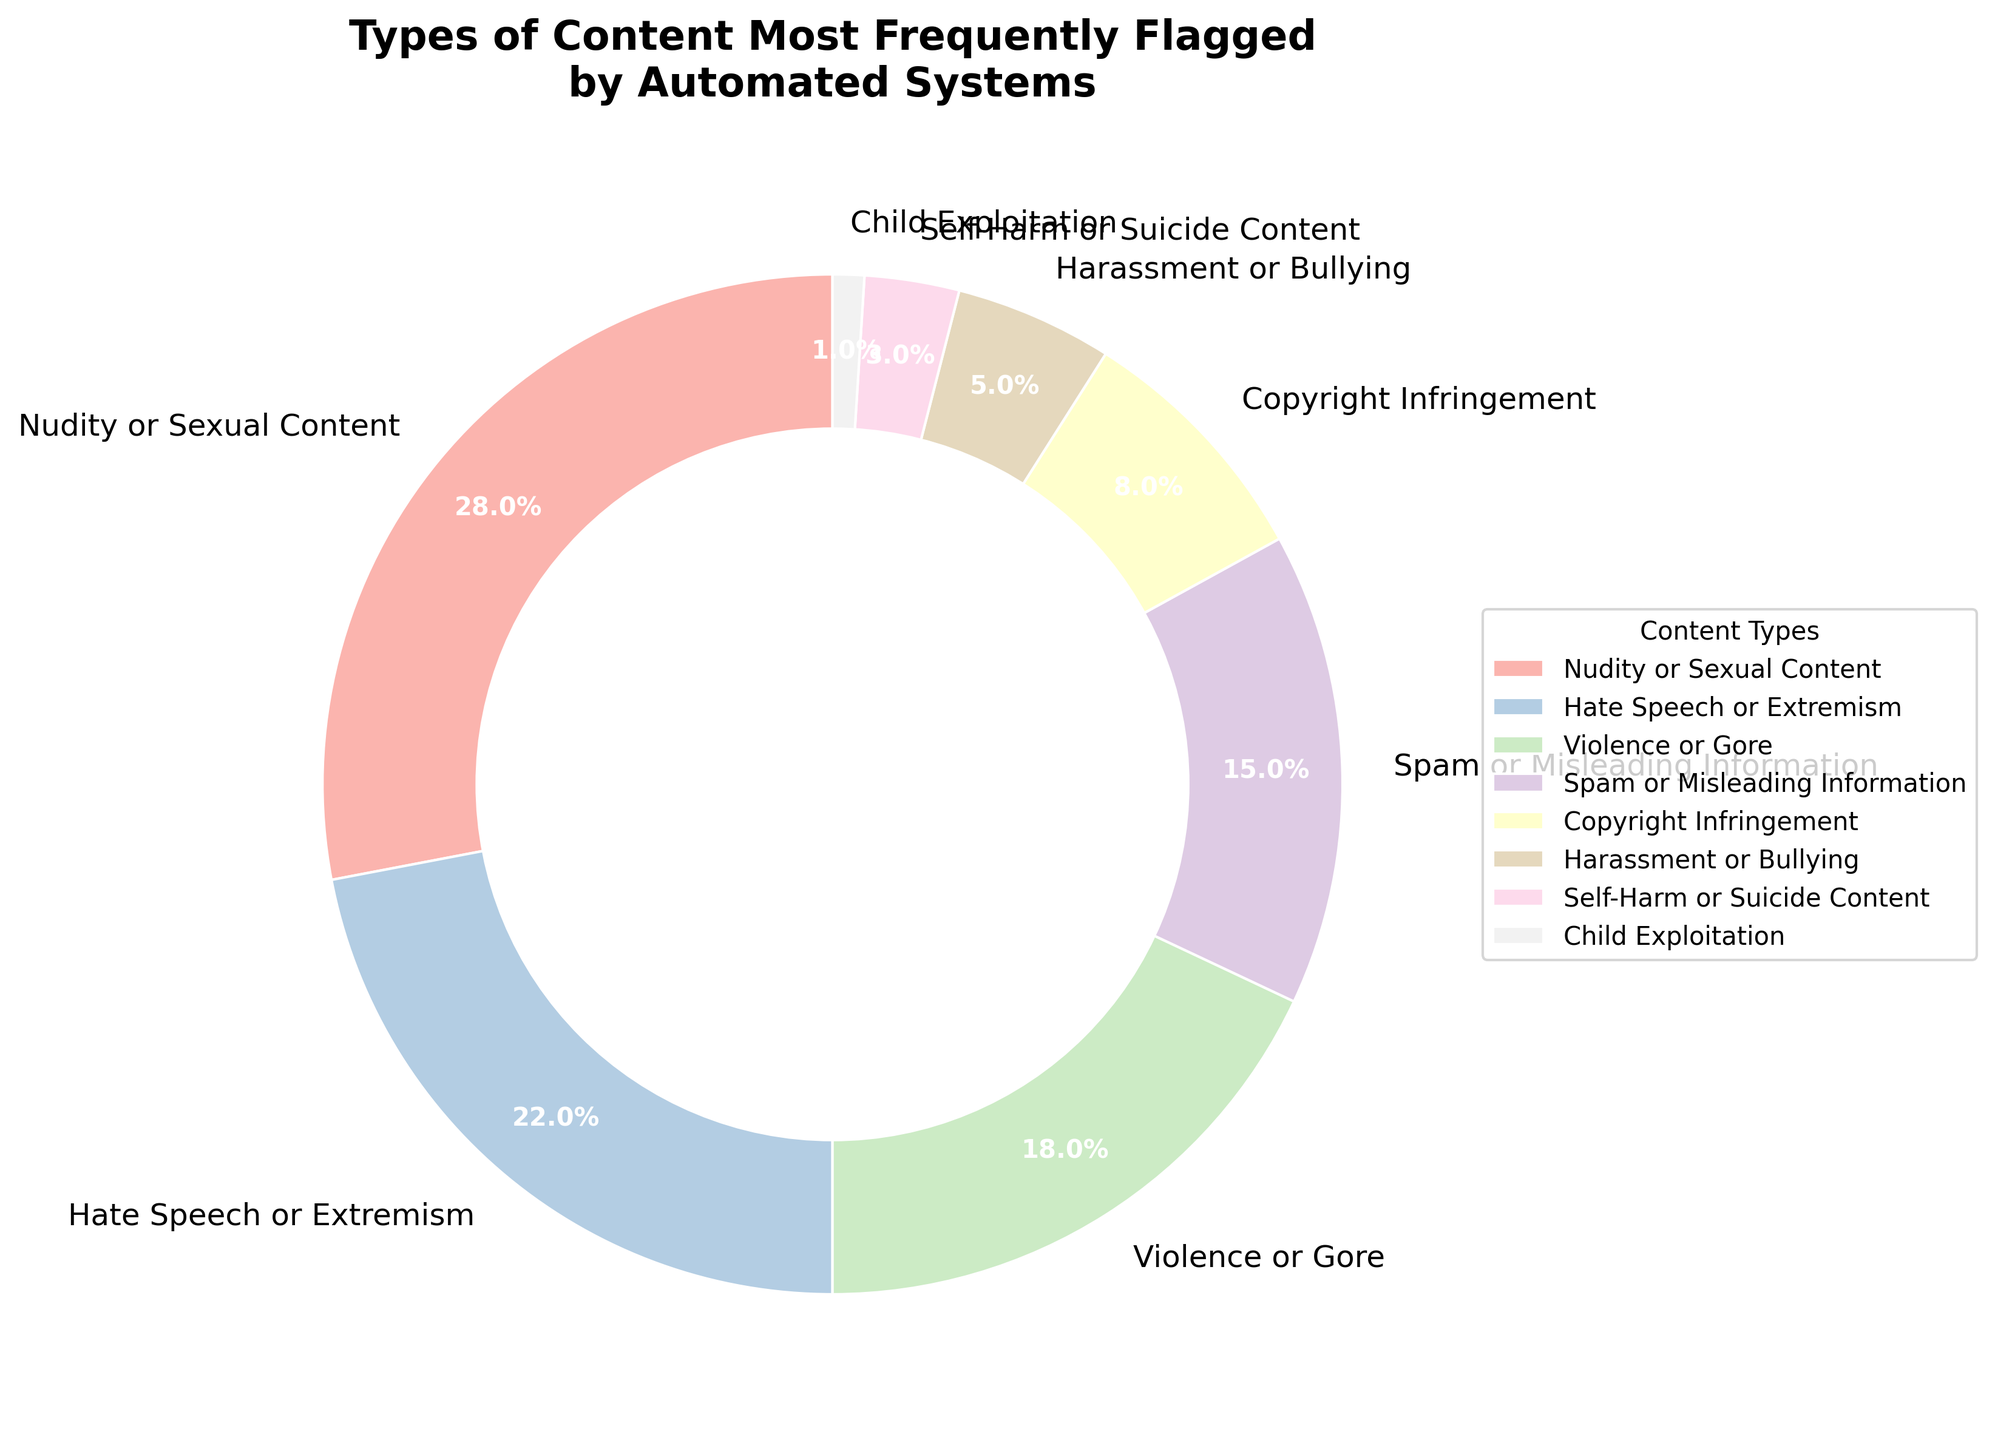What is the most frequently flagged content type according to the pie chart? The most frequently flagged content type is represented by the largest segment of the pie chart. From the visual, "Nudity or Sexual Content" holds the largest percentage at 28%.
Answer: Nudity or Sexual Content Which content type is flagged more frequently: Spam or Misleading Information, or Copyright Infringement? By comparing the sizes of the segments, "Spam or Misleading Information" is represented by a larger segment (15%) compared to "Copyright Infringement" (8%).
Answer: Spam or Misleading Information What is the combined percentage of flagged content for Violence or Gore and Hate Speech or Extremism? Add the percentages of "Violence or Gore" (18%) and "Hate Speech or Extremism" (22%). This gives 18% + 22% = 40%.
Answer: 40% Which content types hold less than 10% of the total flagged content? Identify the segments with percentages under 10%: "Copyright Infringement" (8%), "Harassment or Bullying" (5%), "Self-Harm or Suicide Content" (3%), and "Child Exploitation" (1%).
Answer: Copyright Infringement, Harassment or Bullying, Self-Harm or Suicide Content, Child Exploitation Are there more content types flagged for Spam or Misleading Information and Harassment or Bullying combined than for Nudity or Sexual Content alone? Combine the percentages of "Spam or Misleading Information" (15%) and "Harassment or Bullying" (5%) to get 15% + 5% = 20%. The single percentage of "Nudity or Sexual Content" is 28%, which is higher than 20%.
Answer: No Which content type shows up more frequently: Self-Harm or Suicide Content or Child Exploitation, and by how much? Compare the percentages: "Self-Harm or Suicide Content" is 3% and "Child Exploitation" is 1%. The difference is 3% - 1% = 2%.
Answer: Self-Harm or Suicide Content, by 2% What is the total percentage for content types related to physical harm, including Violence or Gore and Self-Harm or Suicide Content? Add the percentages for "Violence or Gore" (18%) and "Self-Harm or Suicide Content" (3%), resulting in 18% + 3% = 21%.
Answer: 21% 